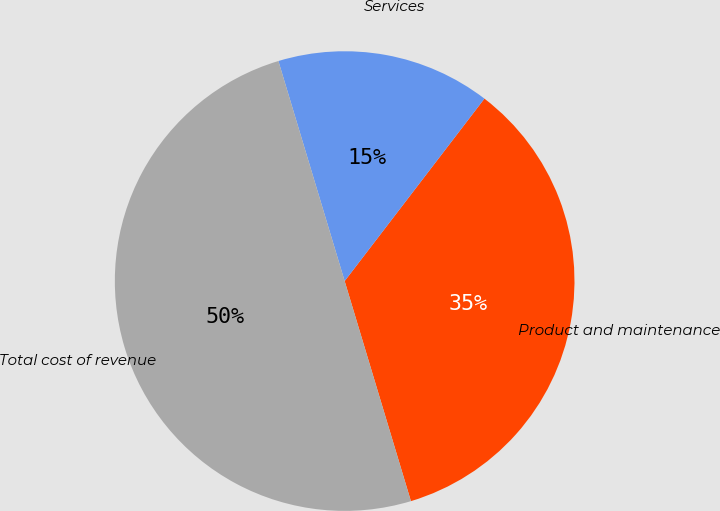Convert chart to OTSL. <chart><loc_0><loc_0><loc_500><loc_500><pie_chart><fcel>Product and maintenance<fcel>Services<fcel>Total cost of revenue<nl><fcel>34.94%<fcel>15.06%<fcel>50.0%<nl></chart> 